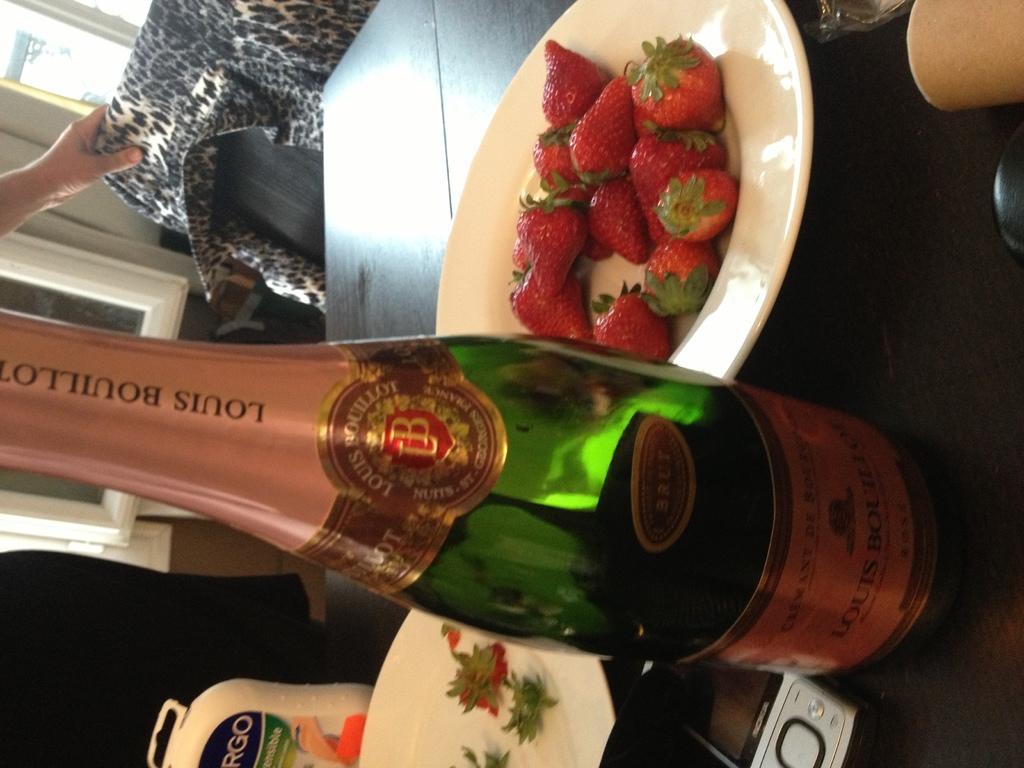Can you describe this image briefly? In this image, we can see a wooden table. On top of that, we can see planets, bottle, mobile and few objects. Here we can see strawberries on the plate. At the bottom of the image, we can see leaves and strawberry pieces. Left side of the image, we can see human hand, chair, clothes, glass objects, wall and few things. 